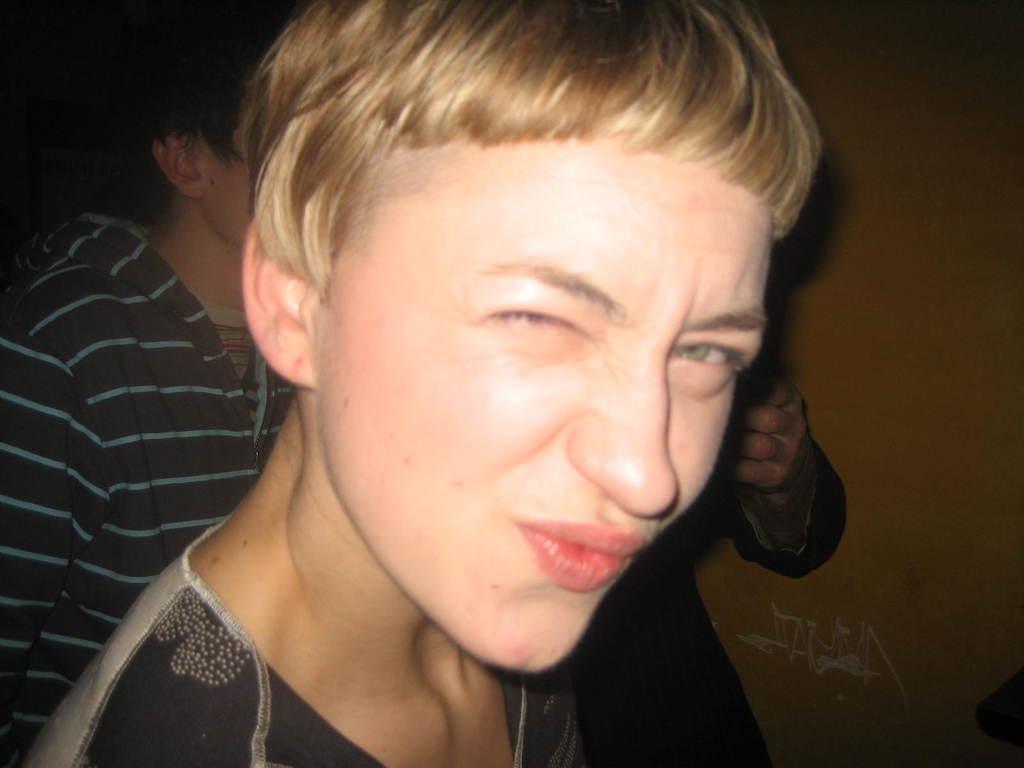Could you give a brief overview of what you see in this image? In this picture I can observe a person wearing black color T shirt. In the background there are some people and I can observe a wall. 